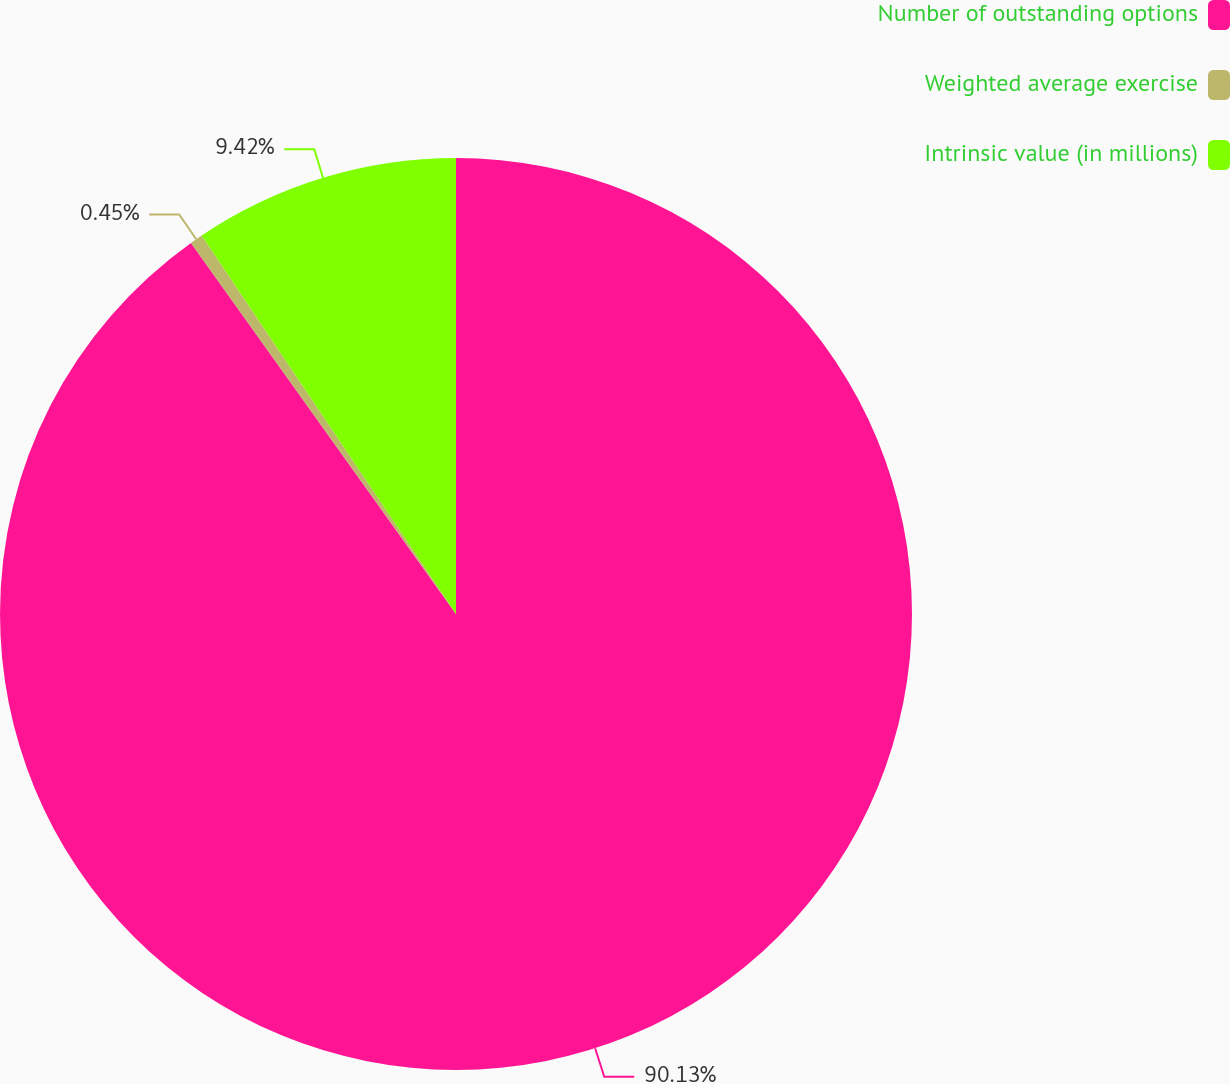Convert chart. <chart><loc_0><loc_0><loc_500><loc_500><pie_chart><fcel>Number of outstanding options<fcel>Weighted average exercise<fcel>Intrinsic value (in millions)<nl><fcel>90.13%<fcel>0.45%<fcel>9.42%<nl></chart> 